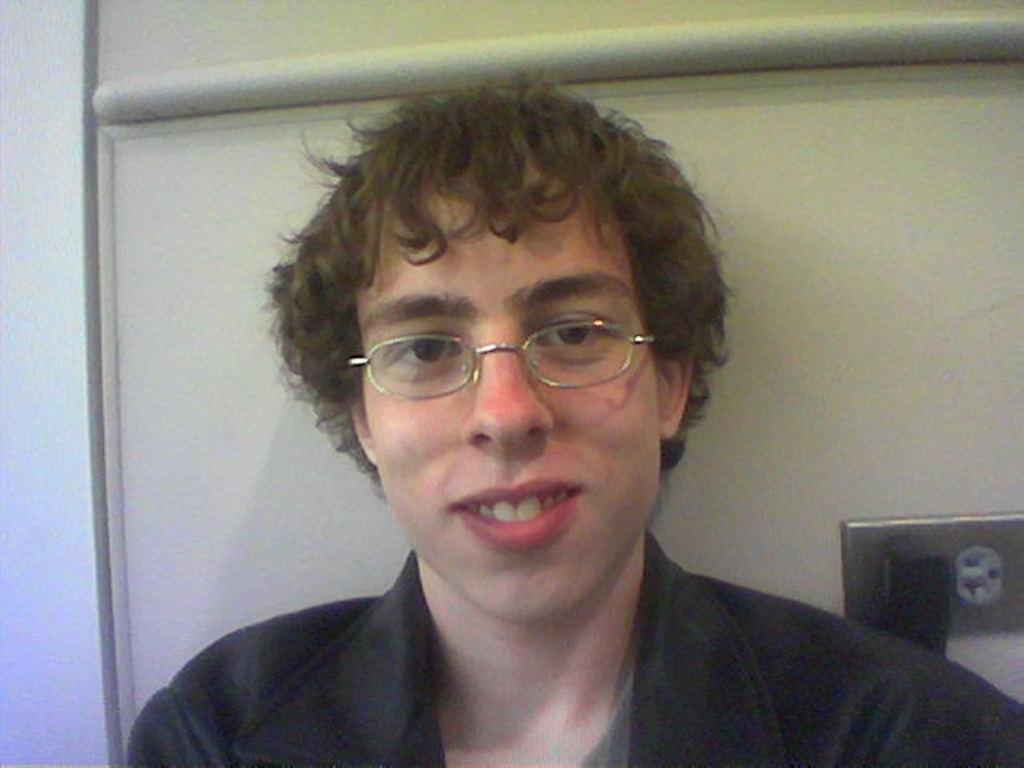What can be seen in the image? There is a person in the image. Can you describe the person's attire? The person is wearing a dress and spectacles. What is visible in the background of the image? There is a wall and a switchboard in the background of the image. What type of vegetable is the person holding in the image? There is no vegetable present in the image; the person is wearing a dress and spectacles. 